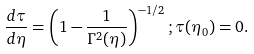<formula> <loc_0><loc_0><loc_500><loc_500>\frac { d \tau } { d \eta } = \left ( 1 - \frac { 1 } { \Gamma ^ { 2 } ( \eta ) } \right ) ^ { - 1 / 2 } ; \tau ( \eta _ { 0 } ) = 0 .</formula> 